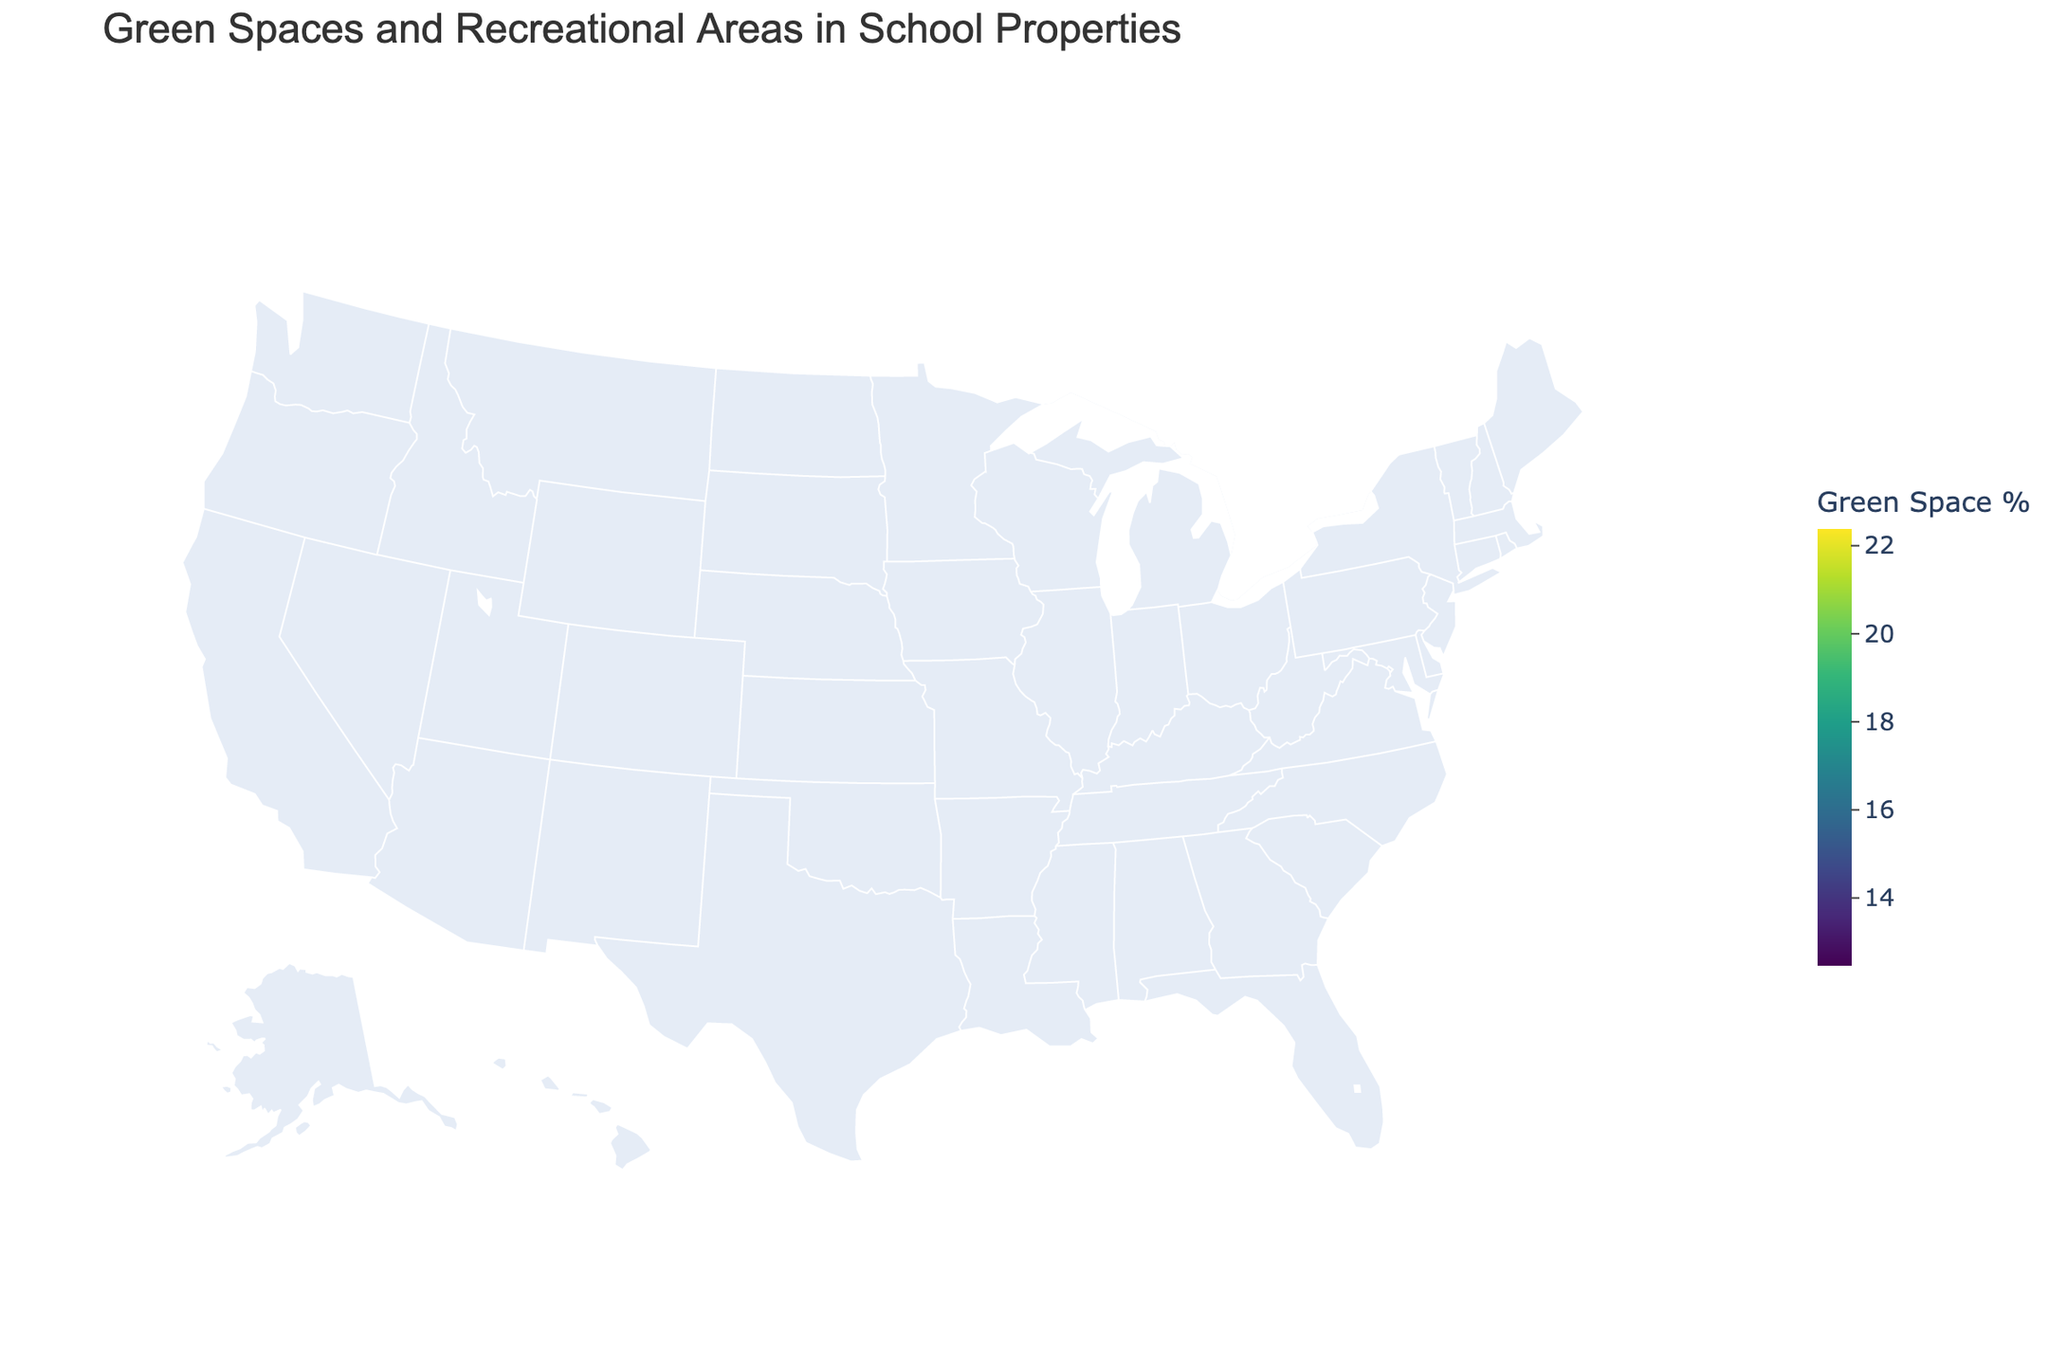What is the title of the figure? The title is displayed at the top of the figure in large font size and reads "Green Spaces and Recreational Areas in School Properties".
Answer: Green Spaces and Recreational Areas in School Properties Which state has the highest Green Space Percentage? On the figure, the color distribution and the data indicate that Washington has the highest Green Space Percentage at 22.4%.
Answer: Washington How does Ohio compare to Florida in terms of Recreational Area per student? The Recreational Area data represented as bubble sizes in the figure show that Ohio has 58 sq ft per student while Florida has 48 sq ft per student.
Answer: Ohio has 10 sq ft more per student Which states have a Green Space Percentage greater than 20%? By examining the states colored darker on the map and referencing the legend, we can see that Georgia, North Carolina, Washington, Tennessee, Wisconsin, Colorado, and Minnesota all have a Green Space Percentage greater than 20%.
Answer: Georgia, North Carolina, Washington, Tennessee, Wisconsin, Colorado, Minnesota What is the average Green Space Percentage of California, Texas, and New York? To find the average, sum the Green Space Percentages of California (15.2), Texas (18.7), and New York (12.5) and then divide by 3: (15.2 + 18.7 + 12.5) / 3 = 15.47%.
Answer: 15.47% Is there a correlation between states with higher Green Space Percentage and larger Recreational Area per student? By observing the map and the bubble sizes, states with higher Green Space Percentages (darker colors) tend generally to have larger Recreational Areas per student (larger bubbles). For instance, Washington and North Carolina have both high Green Space Percentage and large Recreational Areas per student.
Answer: Yes Which states have similar Green Space Percentage values? States like Florida (16.9%), California (15.2%), and Arizona (15.8%) show similar Green Space Percentage values based on their color intensity.
Answer: Florida, California, Arizona Between Virginia and Indiana, which state has a larger Recreational Area per student? The Recreational Area data in the bubble sizes reveal that Indiana has 58 sq ft per student, whereas Virginia has 59 sq ft per student.
Answer: Virginia How many states have a Recreational Area per student of 60 sq ft or more? Rechecking the bubble sizes, five states—North Carolina, Washington, Tennessee, Colorado, and Minnesota—have Recreational Areas per student of 60 sq ft or more.
Answer: Five states 